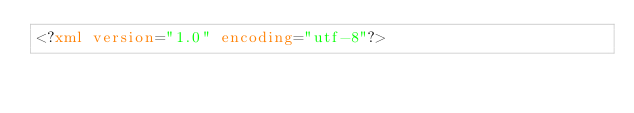<code> <loc_0><loc_0><loc_500><loc_500><_XML_><?xml version="1.0" encoding="utf-8"?>
</code> 